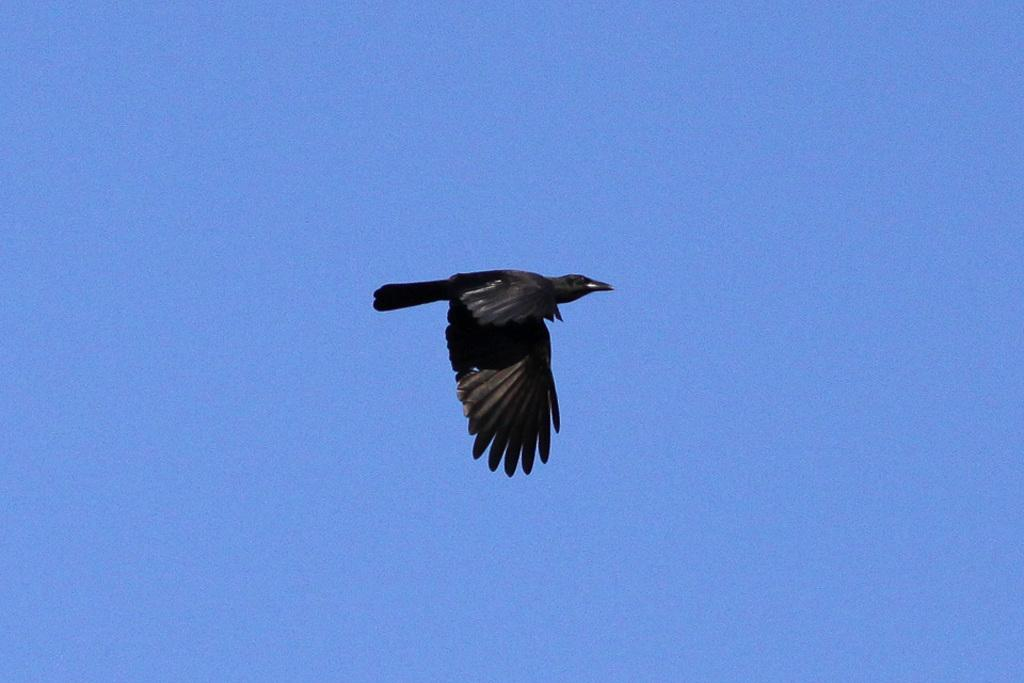What type of animal can be seen in the image? There is a bird in the image. What is the bird doing in the image? The bird is flying in the sky. What type of drink is the bird holding in its beak in the image? There is no drink visible in the image; the bird is simply flying. 